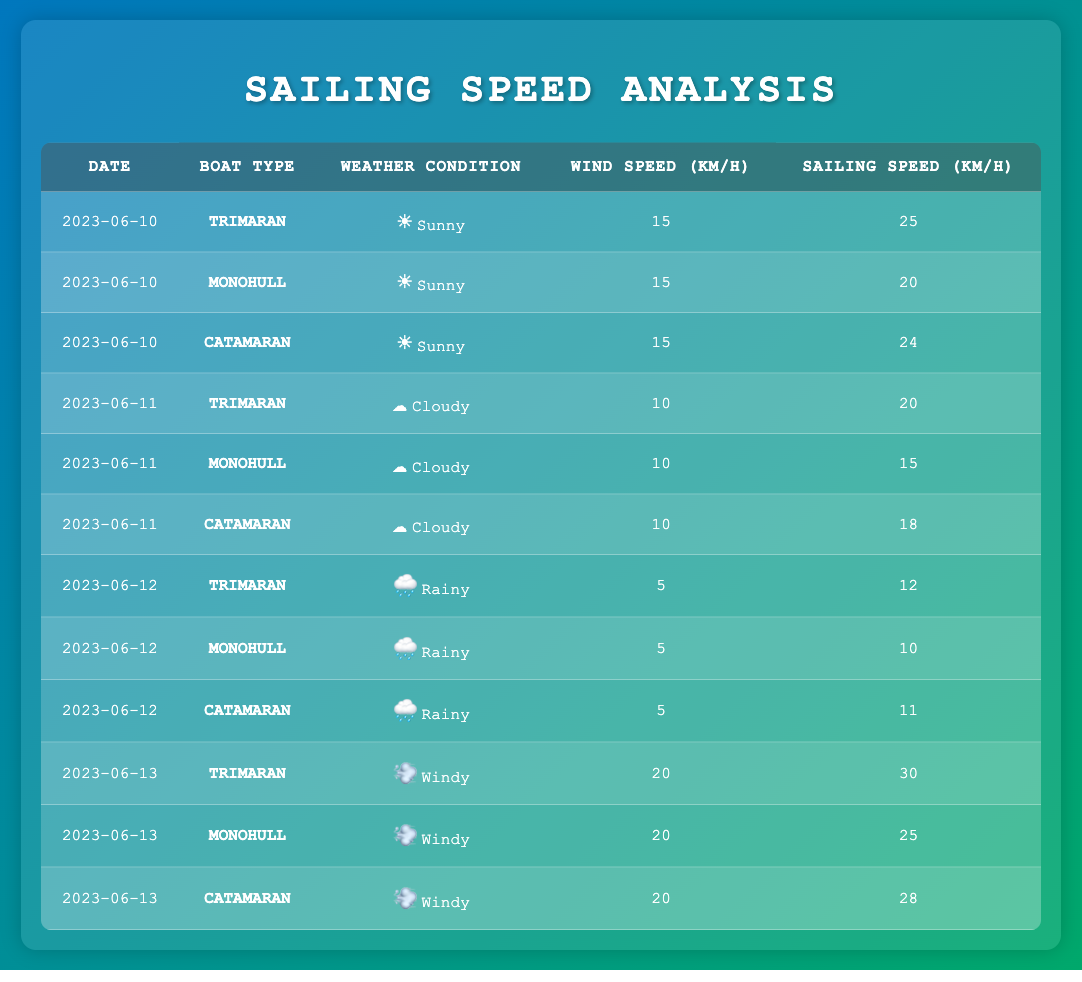What was the sailing speed of the Monohull on June 10, 2023? On June 10, 2023, the sailing speed of the Monohull was recorded in the table under the "Sailing Speed (km/h)" column. The specific entry for the Monohull on that date shows a speed of 20 km/h.
Answer: 20 km/h How many different boat types are represented in the data? The data consists of three different boat types: Trimaran, Monohull, and Catamaran. By examining the entries, we can see that each boat type appears multiple times, confirming the presence of three distinct types.
Answer: 3 What was the average sailing speed of the Trimaran across all dates? The sailing speeds of the Trimaran on the provided dates are 25, 20, 12, and 30 km/h. To calculate the average, we sum these values: 25 + 20 + 12 + 30 = 87. There are four entries, so we divide 87 by 4, resulting in an average of 21.75 km/h.
Answer: 21.75 km/h Was the sailing speed of the Catamaran higher than 25 km/h on any date? By examining the entries for the Catamaran, the speeds listed are 24, 18, 11, and 28 km/h. We see that 28 km/h on June 13 exceeds 25 km/h, confirming that there was one occurrence where the Catamaran's sailing speed was higher than 25 km/h.
Answer: Yes On which date did the Monohull have the lowest sailing speed? The Monohull's sailing speeds from the table are 20, 15, 10, and 25 km/h on different dates. The lowest value is 10 km/h on June 12, which is the corresponding entry for that date.
Answer: June 12, 2023 What was the wind speed during the rainy conditions for Catamarans? According to the entries under rainy weather conditions for Catamarans, the wind speed was recorded at 5 km/h. This information is consistent across all relevant rows for the rainy condition on June 12, 2023.
Answer: 5 km/h Which weather condition correlated with the highest sailing speed for any boat type? Review the sailing speeds in relation to weather conditions. On June 13, under windy conditions, the Trimaran recorded the highest speed at 30 km/h. This indicates that windy weather correlated with the highest sailing speed for the observed boats.
Answer: Windy conditions at 30 km/h What was the difference in sailing speed between Trimaran and Catamaran on June 10? From the table, the Trimaran's speed on that date was 25 km/h and the Catamaran's speed was 24 km/h. The difference is calculated by subtracting the Catamaran's speed from the Trimaran's speed: 25 - 24 = 1 km/h.
Answer: 1 km/h 